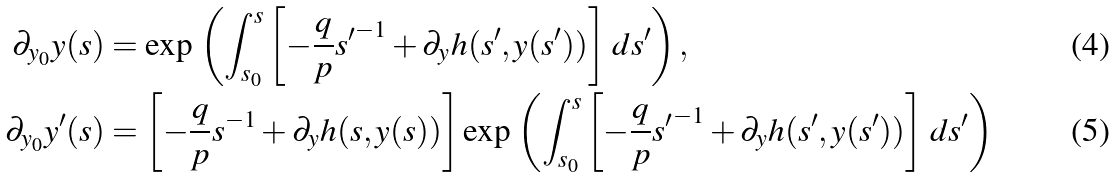<formula> <loc_0><loc_0><loc_500><loc_500>\partial _ { y _ { 0 } } y ( s ) & = \exp \, \left ( \int _ { s _ { 0 } } ^ { s } \left [ { - \frac { q } { p } } { s ^ { \prime } } ^ { - 1 } + \partial _ { y } h ( s ^ { \prime } , y ( s ^ { \prime } ) ) \right ] \, d s ^ { \prime } \right ) , \\ \partial _ { y _ { 0 } } y ^ { \prime } ( s ) & = \left [ { - \frac { q } { p } } s ^ { - 1 } + \partial _ { y } h ( s , y ( s ) ) \right ] \exp \, \left ( \int _ { s _ { 0 } } ^ { s } \left [ { - \frac { q } { p } } { s ^ { \prime } } ^ { - 1 } + \partial _ { y } h ( s ^ { \prime } , y ( s ^ { \prime } ) ) \right ] \, d s ^ { \prime } \right )</formula> 